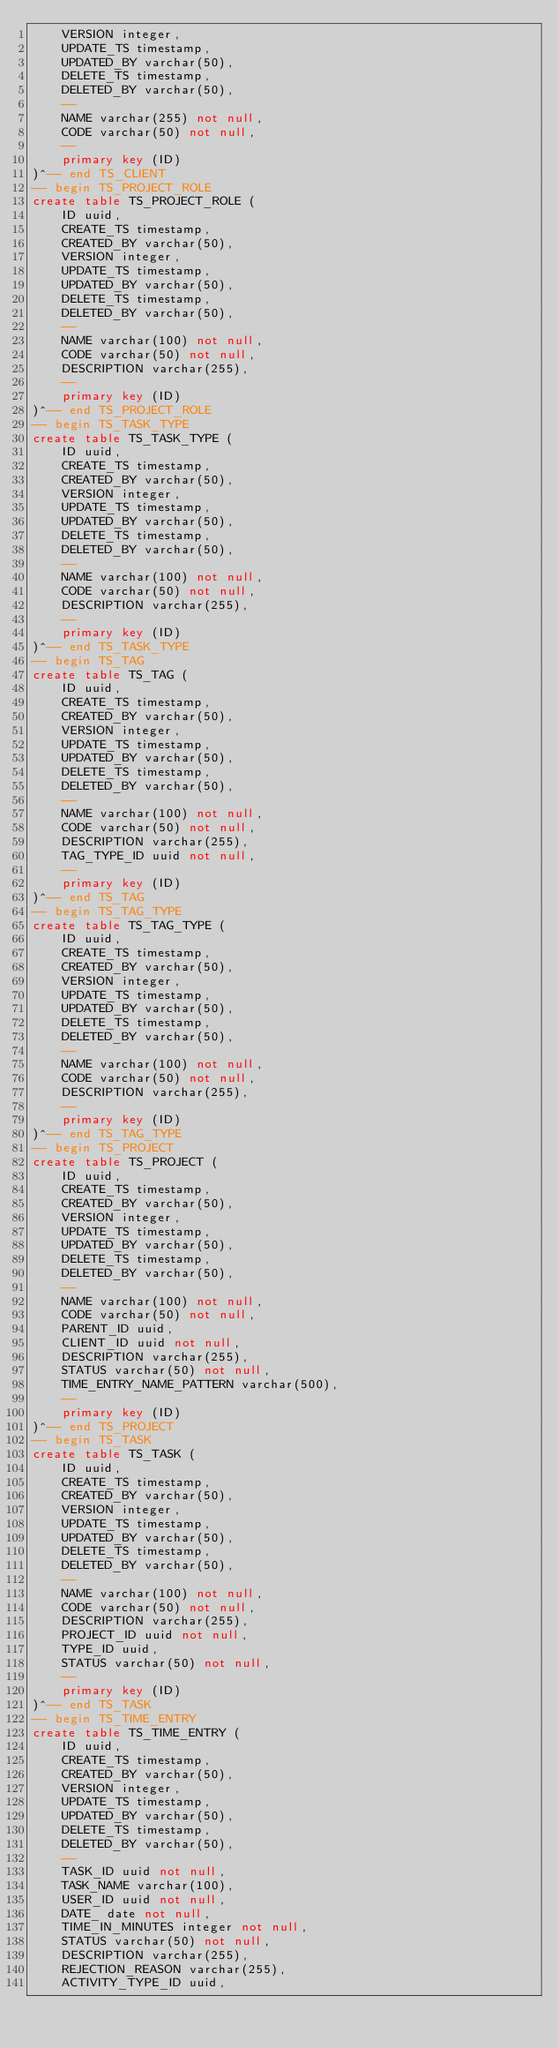Convert code to text. <code><loc_0><loc_0><loc_500><loc_500><_SQL_>    VERSION integer,
    UPDATE_TS timestamp,
    UPDATED_BY varchar(50),
    DELETE_TS timestamp,
    DELETED_BY varchar(50),
    --
    NAME varchar(255) not null,
    CODE varchar(50) not null,
    --
    primary key (ID)
)^-- end TS_CLIENT
-- begin TS_PROJECT_ROLE
create table TS_PROJECT_ROLE (
    ID uuid,
    CREATE_TS timestamp,
    CREATED_BY varchar(50),
    VERSION integer,
    UPDATE_TS timestamp,
    UPDATED_BY varchar(50),
    DELETE_TS timestamp,
    DELETED_BY varchar(50),
    --
    NAME varchar(100) not null,
    CODE varchar(50) not null,
    DESCRIPTION varchar(255),
    --
    primary key (ID)
)^-- end TS_PROJECT_ROLE
-- begin TS_TASK_TYPE
create table TS_TASK_TYPE (
    ID uuid,
    CREATE_TS timestamp,
    CREATED_BY varchar(50),
    VERSION integer,
    UPDATE_TS timestamp,
    UPDATED_BY varchar(50),
    DELETE_TS timestamp,
    DELETED_BY varchar(50),
    --
    NAME varchar(100) not null,
    CODE varchar(50) not null,
    DESCRIPTION varchar(255),
    --
    primary key (ID)
)^-- end TS_TASK_TYPE
-- begin TS_TAG
create table TS_TAG (
    ID uuid,
    CREATE_TS timestamp,
    CREATED_BY varchar(50),
    VERSION integer,
    UPDATE_TS timestamp,
    UPDATED_BY varchar(50),
    DELETE_TS timestamp,
    DELETED_BY varchar(50),
    --
    NAME varchar(100) not null,
    CODE varchar(50) not null,
    DESCRIPTION varchar(255),
    TAG_TYPE_ID uuid not null,
    --
    primary key (ID)
)^-- end TS_TAG
-- begin TS_TAG_TYPE
create table TS_TAG_TYPE (
    ID uuid,
    CREATE_TS timestamp,
    CREATED_BY varchar(50),
    VERSION integer,
    UPDATE_TS timestamp,
    UPDATED_BY varchar(50),
    DELETE_TS timestamp,
    DELETED_BY varchar(50),
    --
    NAME varchar(100) not null,
    CODE varchar(50) not null,
    DESCRIPTION varchar(255),
    --
    primary key (ID)
)^-- end TS_TAG_TYPE
-- begin TS_PROJECT
create table TS_PROJECT (
    ID uuid,
    CREATE_TS timestamp,
    CREATED_BY varchar(50),
    VERSION integer,
    UPDATE_TS timestamp,
    UPDATED_BY varchar(50),
    DELETE_TS timestamp,
    DELETED_BY varchar(50),
    --
    NAME varchar(100) not null,
    CODE varchar(50) not null,
    PARENT_ID uuid,
    CLIENT_ID uuid not null,
    DESCRIPTION varchar(255),
    STATUS varchar(50) not null,
    TIME_ENTRY_NAME_PATTERN varchar(500),
    --
    primary key (ID)
)^-- end TS_PROJECT
-- begin TS_TASK
create table TS_TASK (
    ID uuid,
    CREATE_TS timestamp,
    CREATED_BY varchar(50),
    VERSION integer,
    UPDATE_TS timestamp,
    UPDATED_BY varchar(50),
    DELETE_TS timestamp,
    DELETED_BY varchar(50),
    --
    NAME varchar(100) not null,
    CODE varchar(50) not null,
    DESCRIPTION varchar(255),
    PROJECT_ID uuid not null,
    TYPE_ID uuid,
    STATUS varchar(50) not null,
    --
    primary key (ID)
)^-- end TS_TASK
-- begin TS_TIME_ENTRY
create table TS_TIME_ENTRY (
    ID uuid,
    CREATE_TS timestamp,
    CREATED_BY varchar(50),
    VERSION integer,
    UPDATE_TS timestamp,
    UPDATED_BY varchar(50),
    DELETE_TS timestamp,
    DELETED_BY varchar(50),
    --
    TASK_ID uuid not null,
    TASK_NAME varchar(100),
    USER_ID uuid not null,
    DATE_ date not null,
    TIME_IN_MINUTES integer not null,
    STATUS varchar(50) not null,
    DESCRIPTION varchar(255),
    REJECTION_REASON varchar(255),
    ACTIVITY_TYPE_ID uuid,</code> 